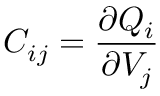<formula> <loc_0><loc_0><loc_500><loc_500>C _ { i j } = { \frac { \partial Q _ { i } } { \partial V _ { j } } }</formula> 